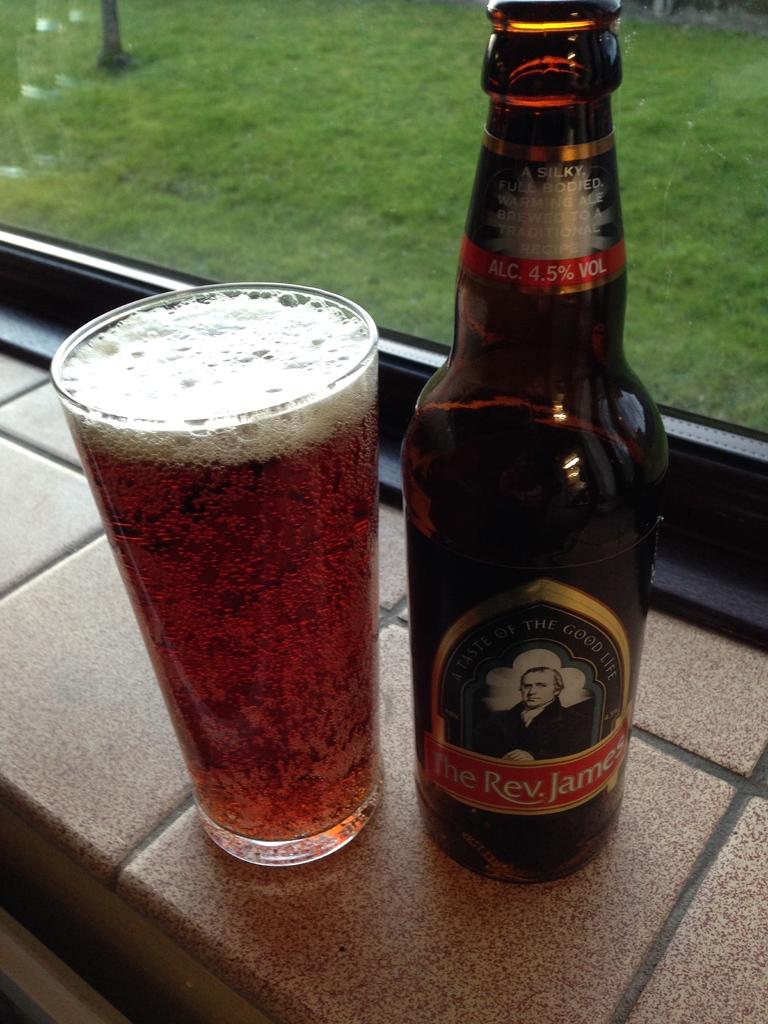What is the name of the beer?
Give a very brief answer. The rev. james. What is the alcohol percentage?
Your response must be concise. 4.5. 